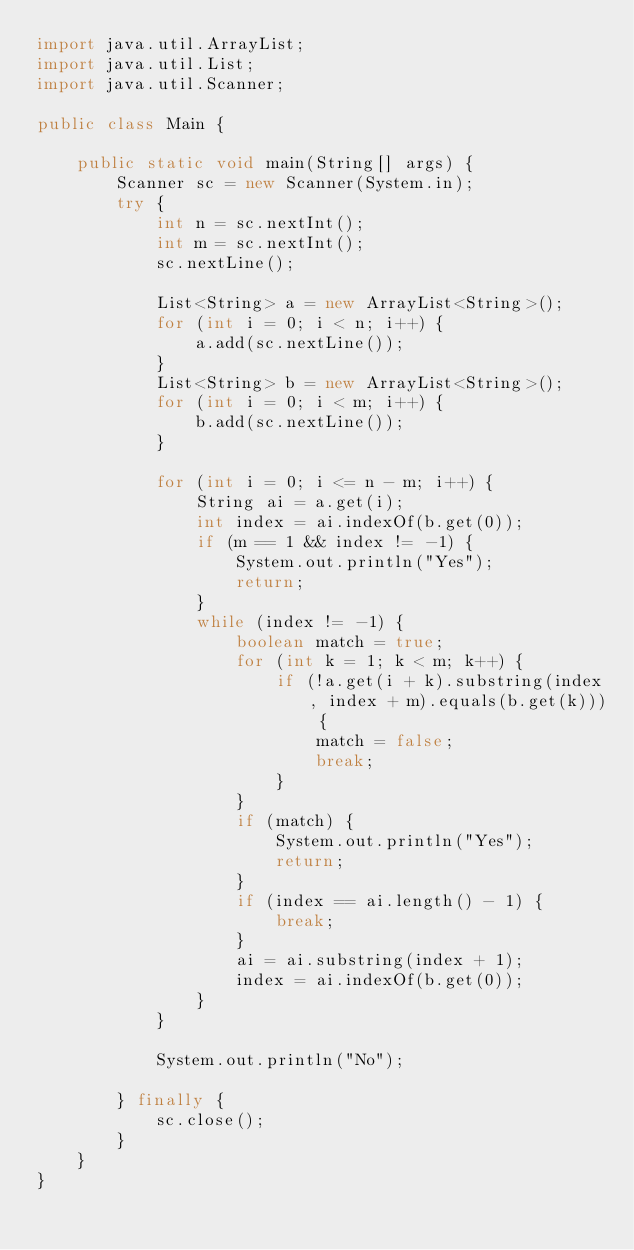Convert code to text. <code><loc_0><loc_0><loc_500><loc_500><_Java_>import java.util.ArrayList;
import java.util.List;
import java.util.Scanner;

public class Main {

	public static void main(String[] args) {
		Scanner sc = new Scanner(System.in);
		try {
			int n = sc.nextInt();
			int m = sc.nextInt();
			sc.nextLine();

			List<String> a = new ArrayList<String>();
			for (int i = 0; i < n; i++) {
				a.add(sc.nextLine());
			}
			List<String> b = new ArrayList<String>();
			for (int i = 0; i < m; i++) {
				b.add(sc.nextLine());
			}

			for (int i = 0; i <= n - m; i++) {
				String ai = a.get(i);
				int index = ai.indexOf(b.get(0));
				if (m == 1 && index != -1) {
					System.out.println("Yes");
					return;
				}
				while (index != -1) {
					boolean match = true;
					for (int k = 1; k < m; k++) {
						if (!a.get(i + k).substring(index, index + m).equals(b.get(k))) {
							match = false;
							break;
						}
					}
					if (match) {
						System.out.println("Yes");
						return;
					}
					if (index == ai.length() - 1) {
						break;
					}
					ai = ai.substring(index + 1);
					index = ai.indexOf(b.get(0));
				}
			}

			System.out.println("No");

		} finally {
			sc.close();
		}
	}
}</code> 